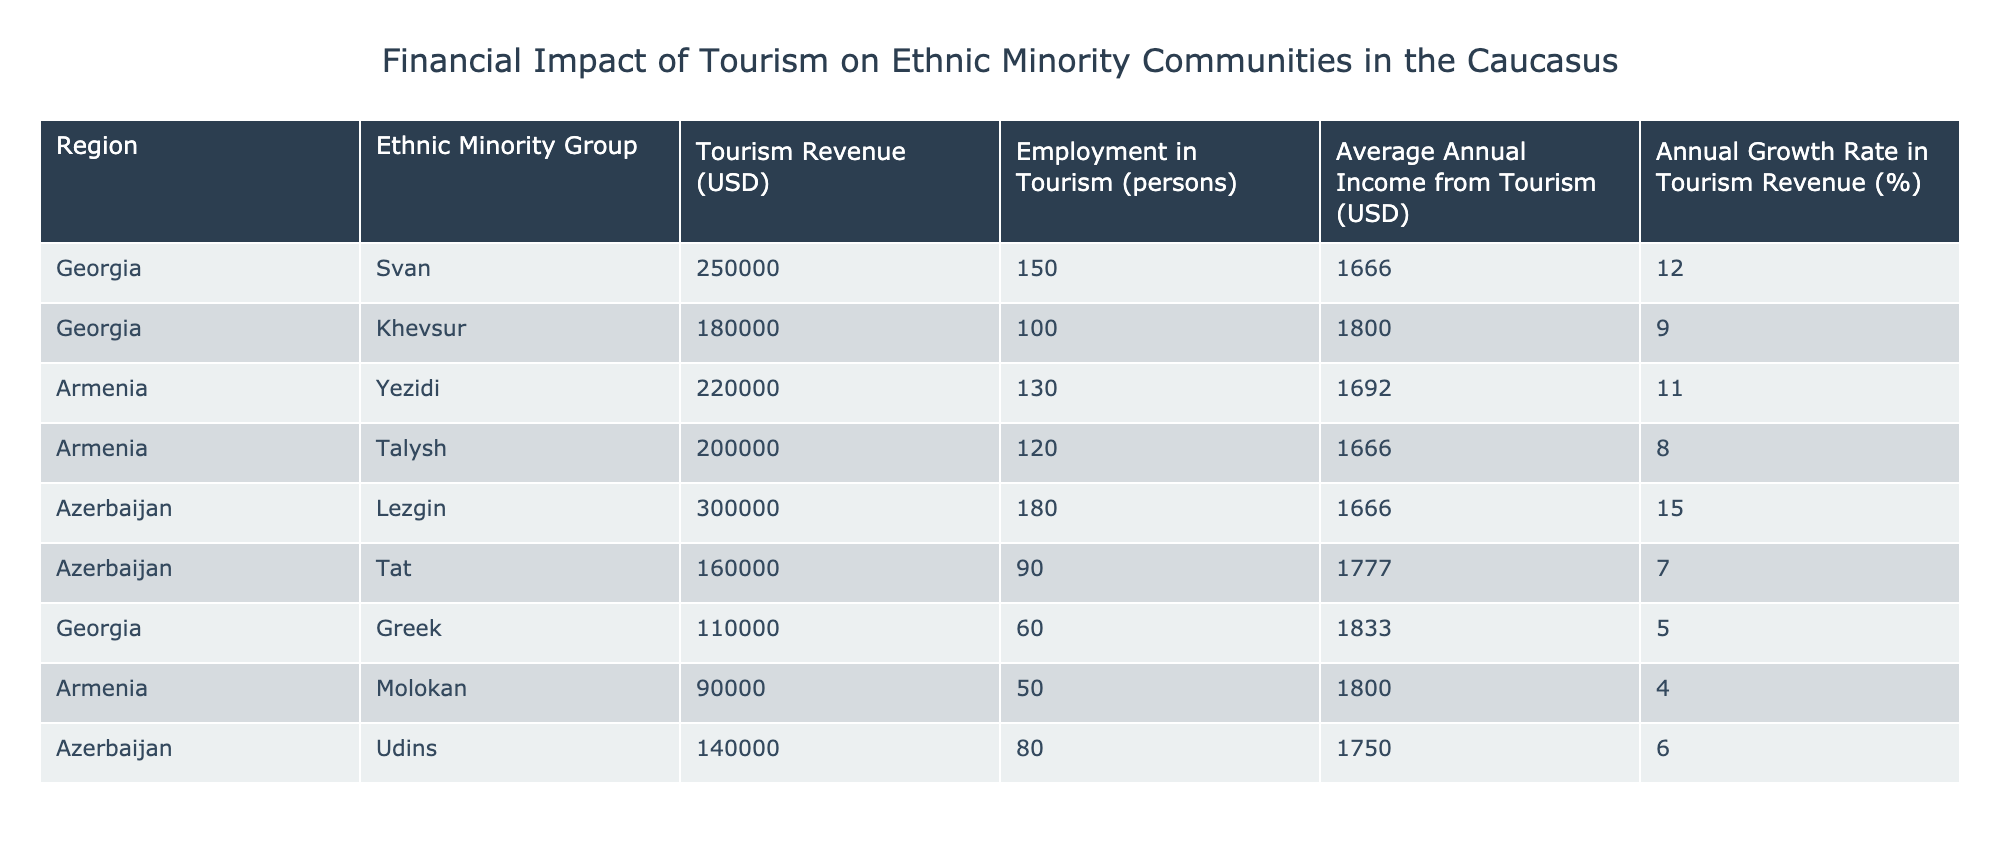What is the total tourism revenue generated by the Lezgin ethnic group? The Lezgin ethnic group in Azerbaijan has a tourism revenue of 300000 USD, as listed in the table.
Answer: 300000 USD Which ethnic minority group has the highest average annual income from tourism? The Lezgin ethnic group has the highest average annual income from tourism at 1666 USD. Checking the average annual income values, the highest is associated with the Lezgin group.
Answer: 1666 USD Calculate the total employment in tourism across all ethnic minority groups in Georgia. In Georgia, the total employment in tourism can be calculated by adding the number of persons employed in each group: Svan (150) + Khevsur (100) + Greek (60) = 310 persons.
Answer: 310 persons Is the tourism revenue growth rate for the Khevsur group higher than that of the Talysh group? The growth rate for the Khevsur group is 9%, while the Talysh group has a growth rate of 8%. Since 9% is greater than 8%, the statement is true.
Answer: Yes What is the average annual income from tourism for all ethnic minority groups combined? To find the average, sum the average annual incomes from each group: (1666 + 1800 + 1692 + 1666 + 1666 + 1777 + 1833 + 1800 + 1750) = 15470. Dividing this by the number of groups (9), we get 15470 / 9 ≈ 1718.89 USD.
Answer: Approximately 1718.89 USD Which region has the least total tourism revenue among the ethnic minority groups? By comparing the tourism revenues of ethnic groups: Georgia (110000 for Greek and 90000 for Molokan) and Armenia (220000 for Yezidi and 200000 for Talysh), the lowest revenue is from the Molokan group at 90000 USD.
Answer: 90000 USD Are there any ethnic minority groups with an annual growth rate of tourism revenue less than 6%? Checking the growth rates: Svan (12%), Khevsur (9%), Yezidi (11%), Talysh (8%), Lezgin (15%), Tat (7%), Greek (5%), Molokan (4%), Udins (6%), the Molokan group has a growth rate of 4%, which is less than 6%. Therefore, the statement is true.
Answer: Yes What is the total tourism revenue generated by all ethnic minority groups in Armenia? The total tourism revenue from the Yezidi (220000) and Talysh (200000) groups is calculated as follows: 220000 + 200000 = 420000 USD.
Answer: 420000 USD 